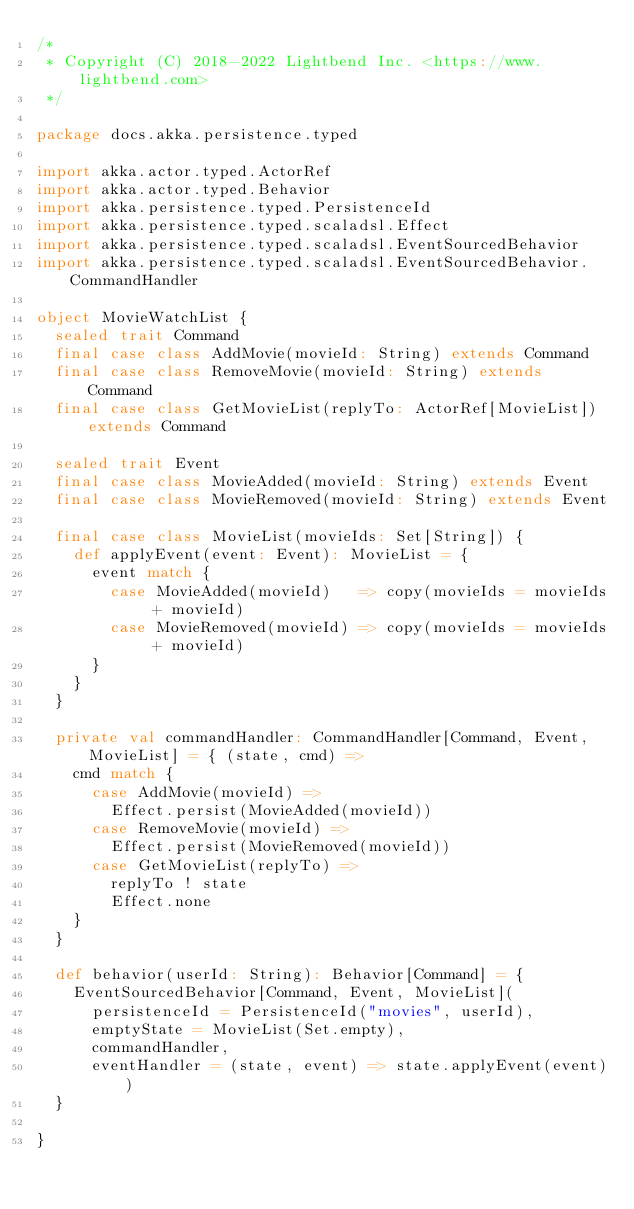<code> <loc_0><loc_0><loc_500><loc_500><_Scala_>/*
 * Copyright (C) 2018-2022 Lightbend Inc. <https://www.lightbend.com>
 */

package docs.akka.persistence.typed

import akka.actor.typed.ActorRef
import akka.actor.typed.Behavior
import akka.persistence.typed.PersistenceId
import akka.persistence.typed.scaladsl.Effect
import akka.persistence.typed.scaladsl.EventSourcedBehavior
import akka.persistence.typed.scaladsl.EventSourcedBehavior.CommandHandler

object MovieWatchList {
  sealed trait Command
  final case class AddMovie(movieId: String) extends Command
  final case class RemoveMovie(movieId: String) extends Command
  final case class GetMovieList(replyTo: ActorRef[MovieList]) extends Command

  sealed trait Event
  final case class MovieAdded(movieId: String) extends Event
  final case class MovieRemoved(movieId: String) extends Event

  final case class MovieList(movieIds: Set[String]) {
    def applyEvent(event: Event): MovieList = {
      event match {
        case MovieAdded(movieId)   => copy(movieIds = movieIds + movieId)
        case MovieRemoved(movieId) => copy(movieIds = movieIds + movieId)
      }
    }
  }

  private val commandHandler: CommandHandler[Command, Event, MovieList] = { (state, cmd) =>
    cmd match {
      case AddMovie(movieId) =>
        Effect.persist(MovieAdded(movieId))
      case RemoveMovie(movieId) =>
        Effect.persist(MovieRemoved(movieId))
      case GetMovieList(replyTo) =>
        replyTo ! state
        Effect.none
    }
  }

  def behavior(userId: String): Behavior[Command] = {
    EventSourcedBehavior[Command, Event, MovieList](
      persistenceId = PersistenceId("movies", userId),
      emptyState = MovieList(Set.empty),
      commandHandler,
      eventHandler = (state, event) => state.applyEvent(event))
  }

}
</code> 